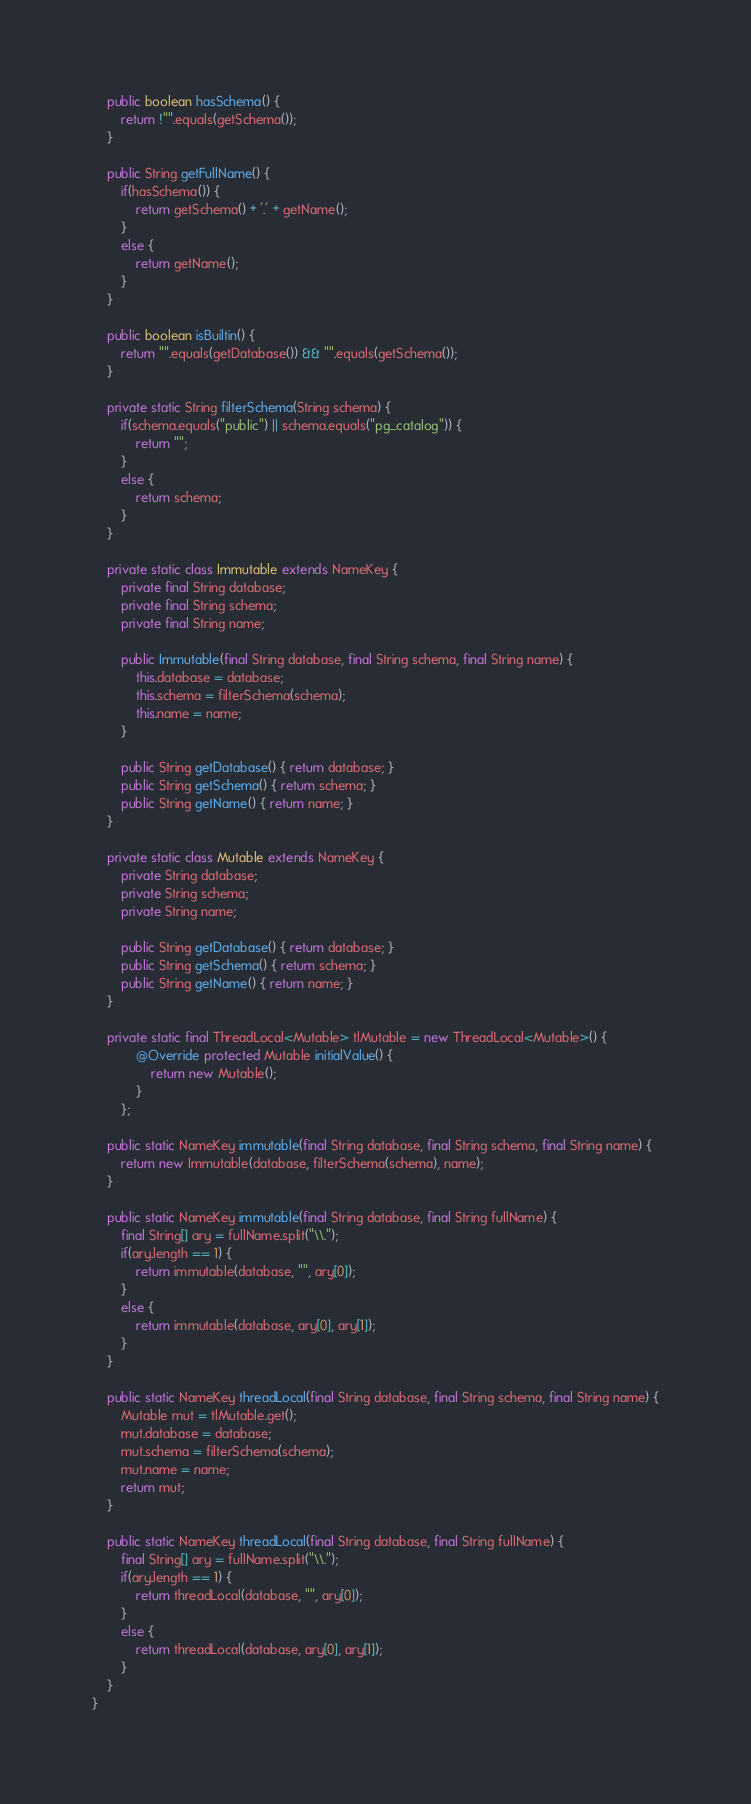<code> <loc_0><loc_0><loc_500><loc_500><_Java_>    public boolean hasSchema() {
        return !"".equals(getSchema());
    }
    
    public String getFullName() {
        if(hasSchema()) {
            return getSchema() + '.' + getName();
        }
        else {
            return getName();
        }
    }

    public boolean isBuiltin() {
        return "".equals(getDatabase()) && "".equals(getSchema());
    }

    private static String filterSchema(String schema) {
        if(schema.equals("public") || schema.equals("pg_catalog")) {
            return "";
        }
        else {
            return schema;
        }
    }

    private static class Immutable extends NameKey {
        private final String database;
        private final String schema;
        private final String name;

        public Immutable(final String database, final String schema, final String name) {
            this.database = database;
            this.schema = filterSchema(schema);
            this.name = name;
        }

        public String getDatabase() { return database; }
        public String getSchema() { return schema; }
        public String getName() { return name; }
    }

    private static class Mutable extends NameKey {
        private String database;
        private String schema;
        private String name;
        
        public String getDatabase() { return database; }
        public String getSchema() { return schema; }
        public String getName() { return name; }
    }

    private static final ThreadLocal<Mutable> tlMutable = new ThreadLocal<Mutable>() {
            @Override protected Mutable initialValue() {
                return new Mutable();
            }
        };

    public static NameKey immutable(final String database, final String schema, final String name) {
        return new Immutable(database, filterSchema(schema), name);
    }

    public static NameKey immutable(final String database, final String fullName) {
        final String[] ary = fullName.split("\\.");
        if(ary.length == 1) {
            return immutable(database, "", ary[0]);
        }
        else {
            return immutable(database, ary[0], ary[1]);
        }
    }

    public static NameKey threadLocal(final String database, final String schema, final String name) {
        Mutable mut = tlMutable.get();
        mut.database = database;
        mut.schema = filterSchema(schema);
        mut.name = name;
        return mut;
    }

    public static NameKey threadLocal(final String database, final String fullName) {
        final String[] ary = fullName.split("\\.");
        if(ary.length == 1) {
            return threadLocal(database, "", ary[0]);
        }
        else {
            return threadLocal(database, ary[0], ary[1]);
        }
    }
}
</code> 